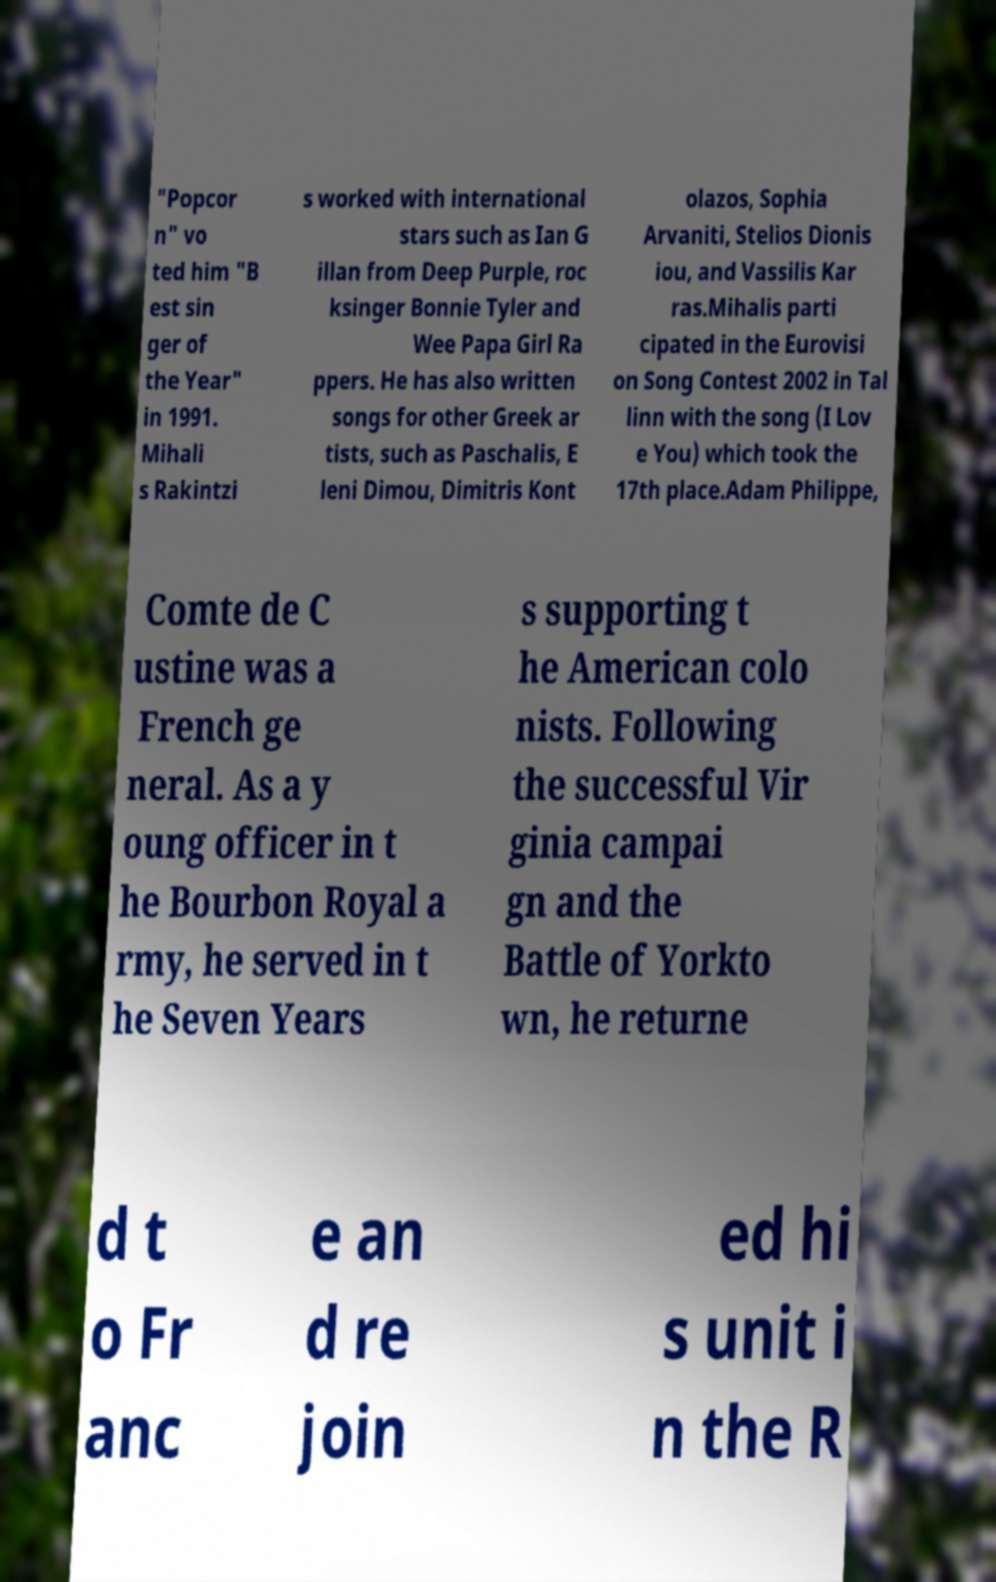I need the written content from this picture converted into text. Can you do that? "Popcor n" vo ted him "B est sin ger of the Year" in 1991. Mihali s Rakintzi s worked with international stars such as Ian G illan from Deep Purple, roc ksinger Bonnie Tyler and Wee Papa Girl Ra ppers. He has also written songs for other Greek ar tists, such as Paschalis, E leni Dimou, Dimitris Kont olazos, Sophia Arvaniti, Stelios Dionis iou, and Vassilis Kar ras.Mihalis parti cipated in the Eurovisi on Song Contest 2002 in Tal linn with the song (I Lov e You) which took the 17th place.Adam Philippe, Comte de C ustine was a French ge neral. As a y oung officer in t he Bourbon Royal a rmy, he served in t he Seven Years s supporting t he American colo nists. Following the successful Vir ginia campai gn and the Battle of Yorkto wn, he returne d t o Fr anc e an d re join ed hi s unit i n the R 